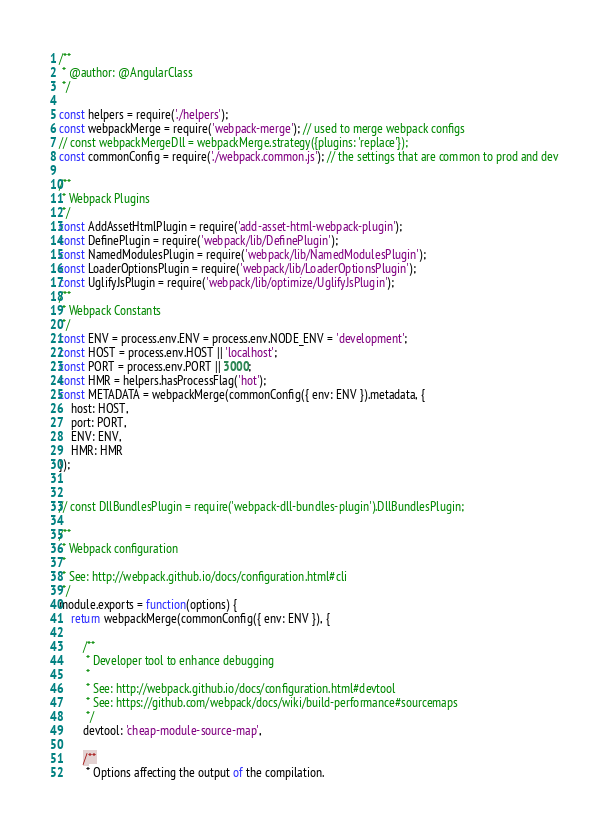Convert code to text. <code><loc_0><loc_0><loc_500><loc_500><_JavaScript_>/**
 * @author: @AngularClass
 */

const helpers = require('./helpers');
const webpackMerge = require('webpack-merge'); // used to merge webpack configs
// const webpackMergeDll = webpackMerge.strategy({plugins: 'replace'});
const commonConfig = require('./webpack.common.js'); // the settings that are common to prod and dev

/**
 * Webpack Plugins
 */
const AddAssetHtmlPlugin = require('add-asset-html-webpack-plugin');
const DefinePlugin = require('webpack/lib/DefinePlugin');
const NamedModulesPlugin = require('webpack/lib/NamedModulesPlugin');
const LoaderOptionsPlugin = require('webpack/lib/LoaderOptionsPlugin');
const UglifyJsPlugin = require('webpack/lib/optimize/UglifyJsPlugin');
/**
 * Webpack Constants
 */
const ENV = process.env.ENV = process.env.NODE_ENV = 'development';
const HOST = process.env.HOST || 'localhost';
const PORT = process.env.PORT || 3000;
const HMR = helpers.hasProcessFlag('hot');
const METADATA = webpackMerge(commonConfig({ env: ENV }).metadata, {
    host: HOST,
    port: PORT,
    ENV: ENV,
    HMR: HMR
});


// const DllBundlesPlugin = require('webpack-dll-bundles-plugin').DllBundlesPlugin;

/**
 * Webpack configuration
 *
 * See: http://webpack.github.io/docs/configuration.html#cli
 */
module.exports = function(options) {
    return webpackMerge(commonConfig({ env: ENV }), {

        /**
         * Developer tool to enhance debugging
         *
         * See: http://webpack.github.io/docs/configuration.html#devtool
         * See: https://github.com/webpack/docs/wiki/build-performance#sourcemaps
         */
        devtool: 'cheap-module-source-map',

        /**
         * Options affecting the output of the compilation.</code> 